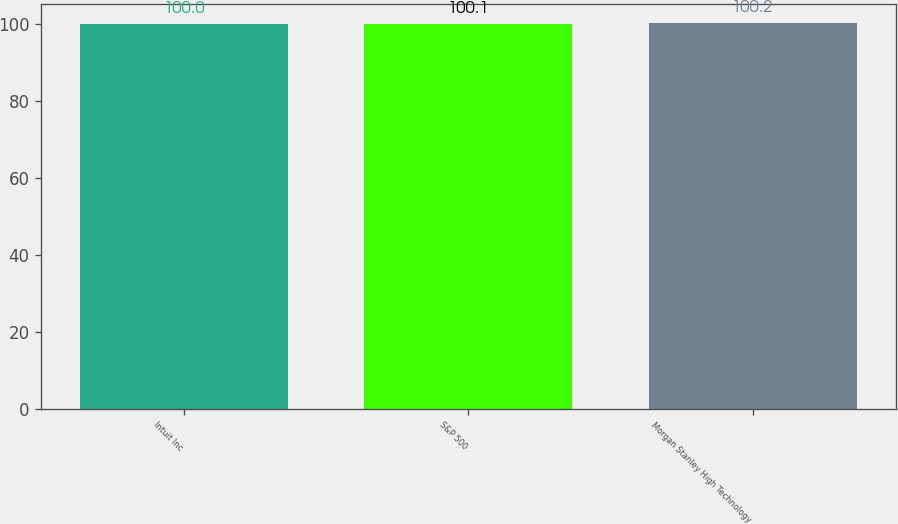Convert chart. <chart><loc_0><loc_0><loc_500><loc_500><bar_chart><fcel>Intuit Inc<fcel>S&P 500<fcel>Morgan Stanley High Technology<nl><fcel>100<fcel>100.1<fcel>100.2<nl></chart> 